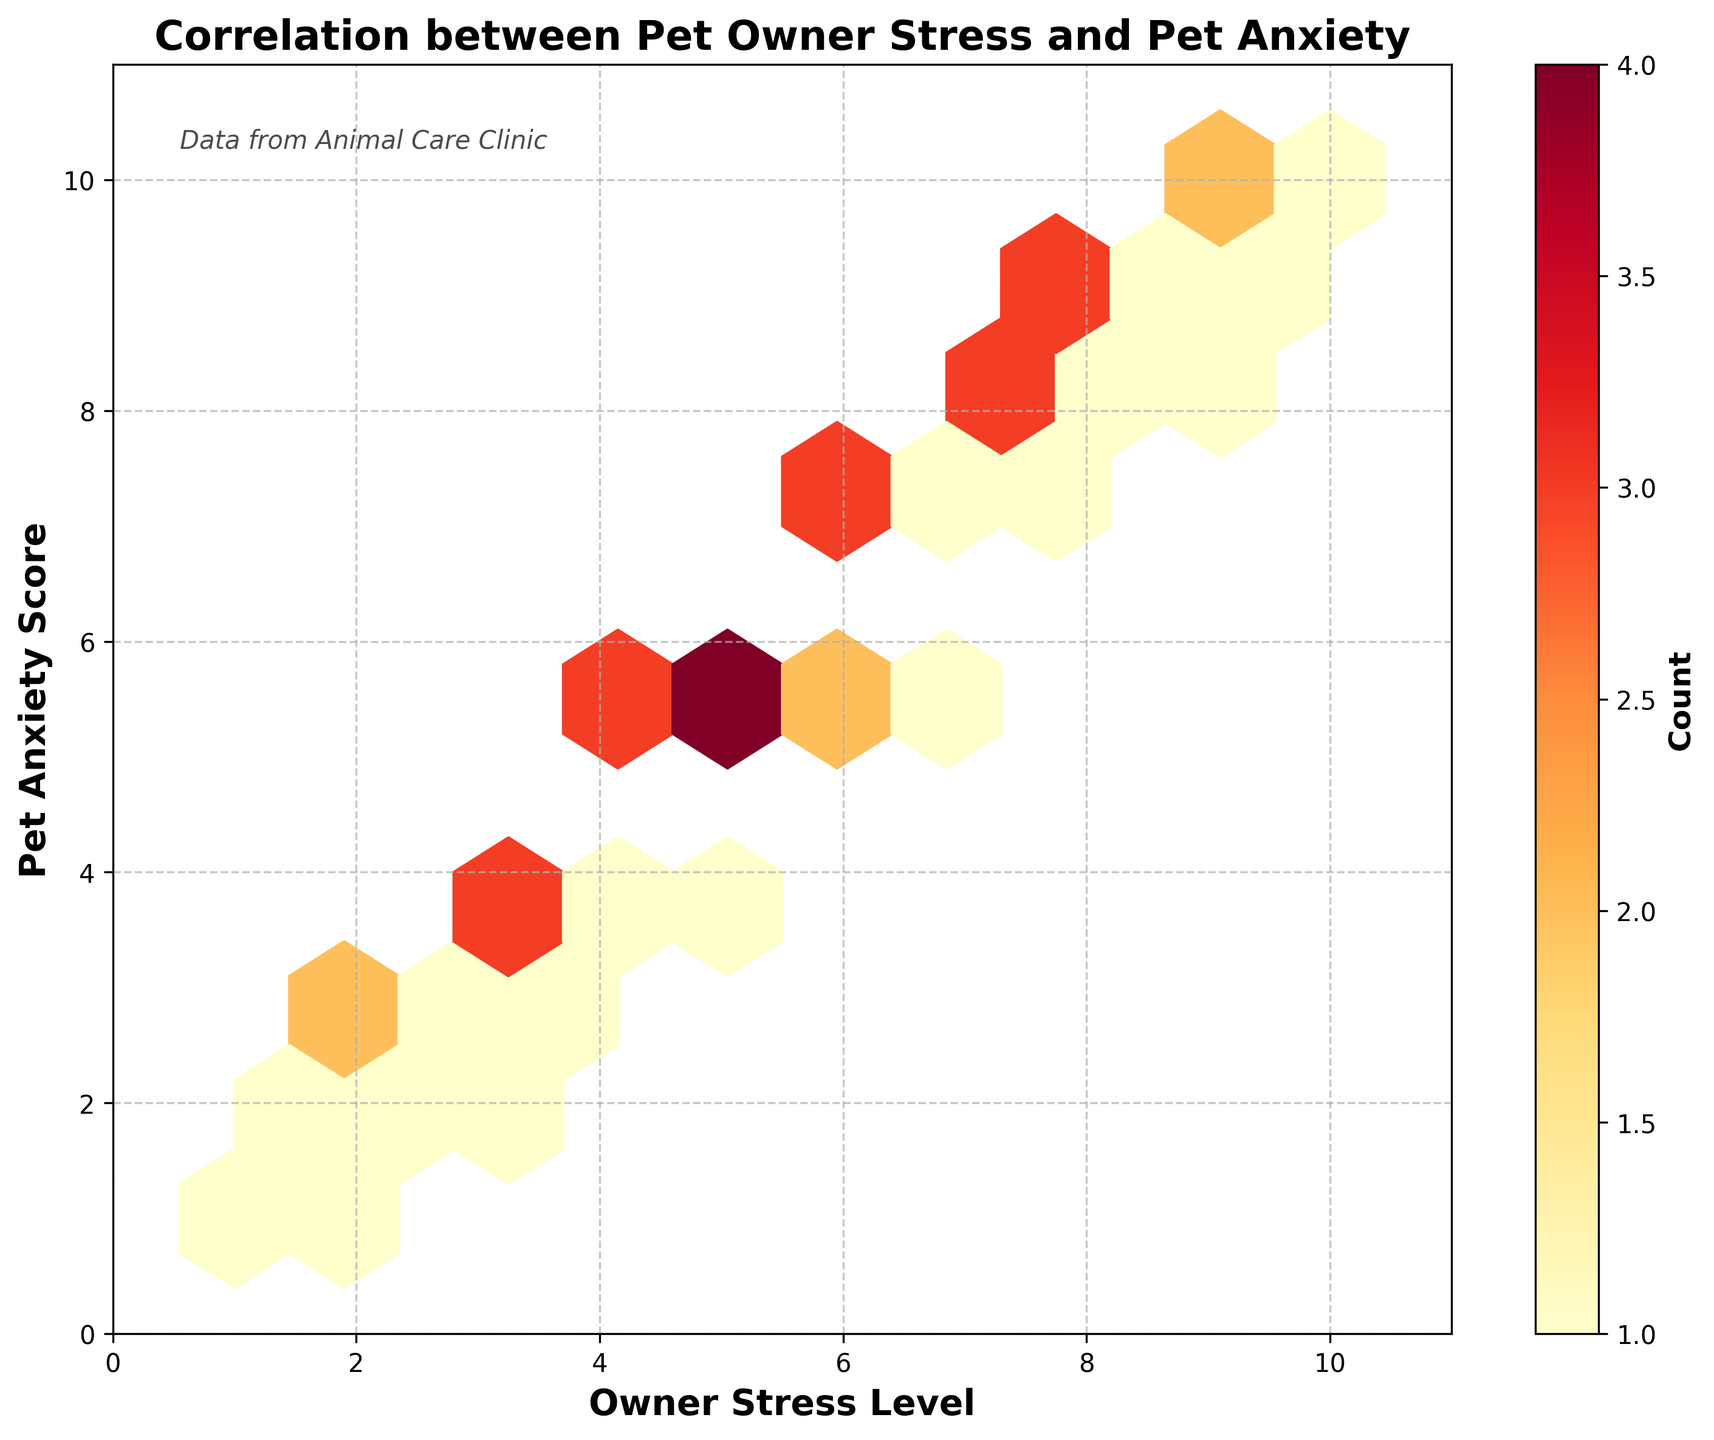What is the title of the plot? The title is located at the top of the plot and describes the main theme.
Answer: Correlation between Pet Owner Stress and Pet Anxiety What does the color intensity in the hexagonal bins represent? The color intensity indicates the count of data points within each hexagonal bin. Bins with more data points have higher color intensity.
Answer: Count of data points What is the range of the x-axis? The x-axis represents the Owner Stress Level, and the range is identified by looking at the minimum and maximum values along this axis.
Answer: 0 to 11 What is the color of the bins with the highest concentration of data points? The color of the bins with the highest concentration can be identified from the color map used in the hexbin plot.
Answer: Dark red In what general pattern do the Owner Stress Level and Pet Anxiety Score appear to be related? By observing the overall trend of the data points, if the Owner Stress Level increases or decreases with the Pet Anxiety Score, it suggests a certain pattern.
Answer: Positive correlation Which axis has more spread in data points? By observing the range of values and distribution along both axes, we can determine which axis shows more spread.
Answer: Both axes show similar spread How many bins contain the maximum count of data points? By observing the bin with the darkest color and counting how many such bins exist, we determine the number of bins with the maximum count.
Answer: One What is the range of the y-axis? The y-axis represents the Pet Anxiety Score, and its range can be identified by looking for the minimum and maximum values along this axis.
Answer: 0 to 11 How does the number of data points change as the Owner Stress Level increases from 2 to 5? By examining the color intensity changes along the x-axis from 2 to 5, we can infer how the number of data points varies.
Answer: Increases What is the purpose of the color bar? The color bar indicates the count of data points in the hexagonal bins, providing a key to understanding color intensity.
Answer: To show the count of data points in bins 